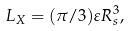Convert formula to latex. <formula><loc_0><loc_0><loc_500><loc_500>L _ { X } = ( \pi / 3 ) \varepsilon R _ { s } ^ { 3 } ,</formula> 